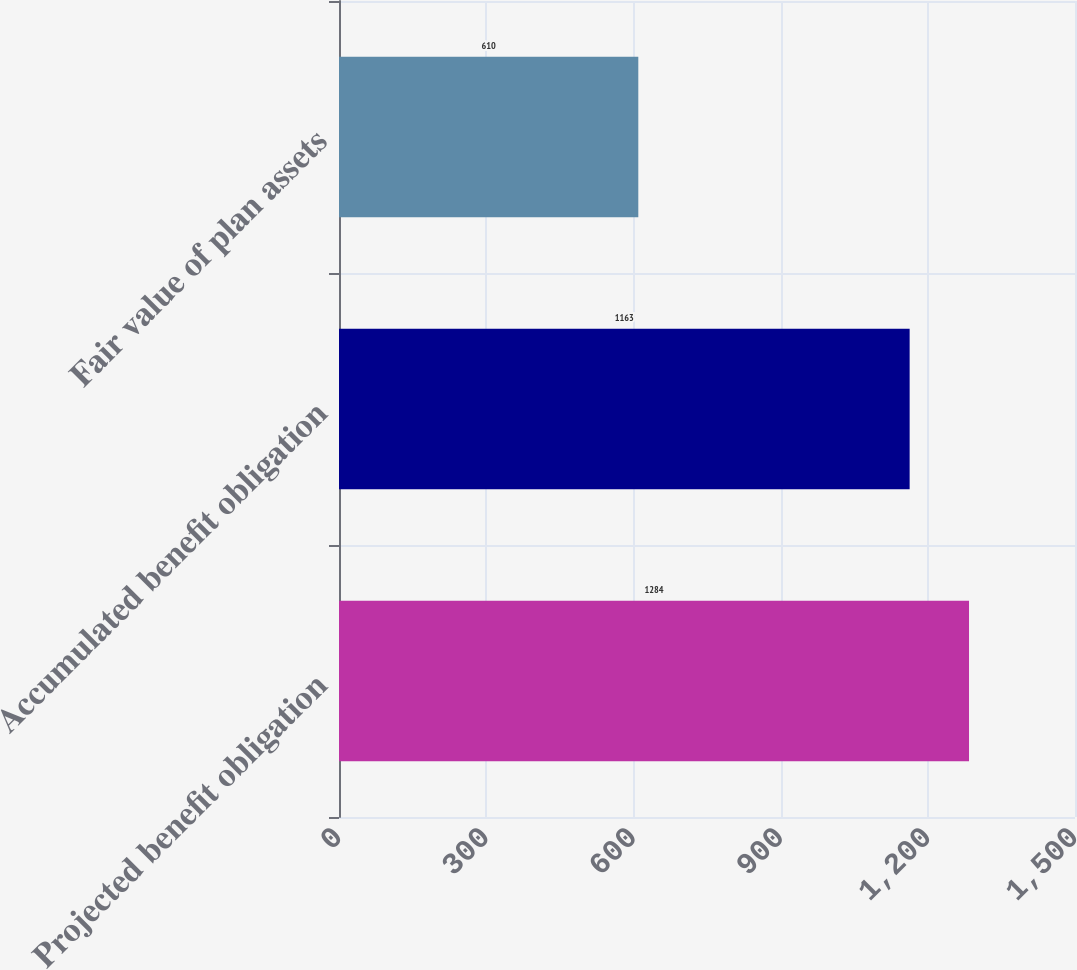<chart> <loc_0><loc_0><loc_500><loc_500><bar_chart><fcel>Projected benefit obligation<fcel>Accumulated benefit obligation<fcel>Fair value of plan assets<nl><fcel>1284<fcel>1163<fcel>610<nl></chart> 